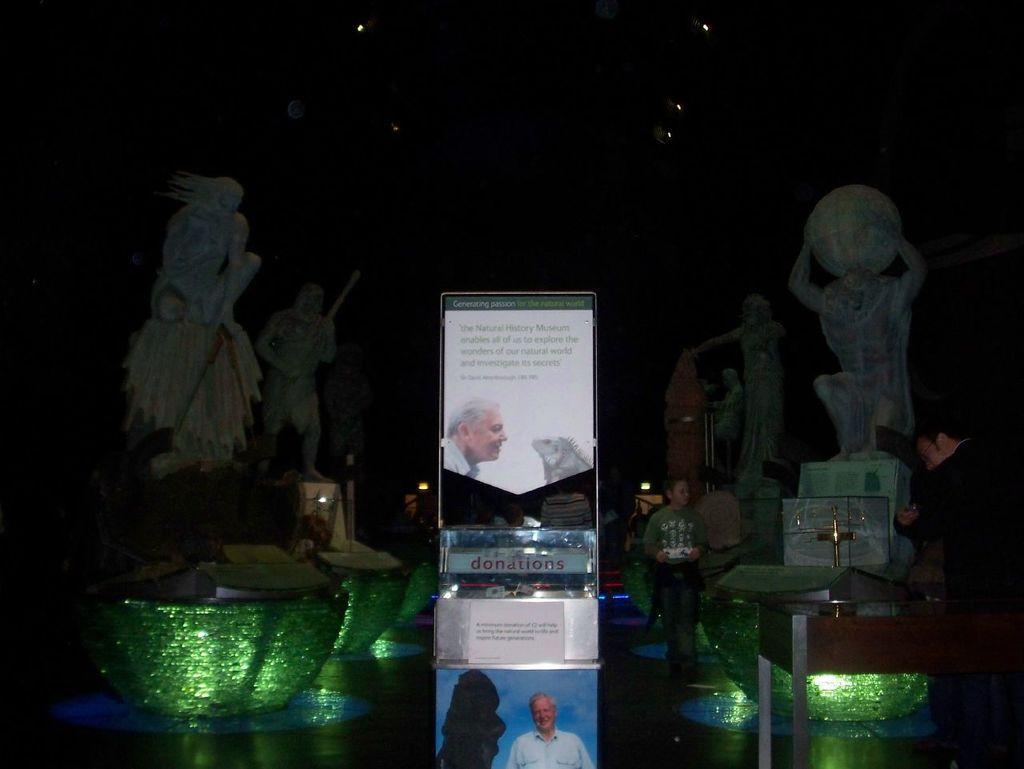Please provide a concise description of this image. In this image there are statues, boards, poster, people, lights and objects. Something is written on the boards and poster. 